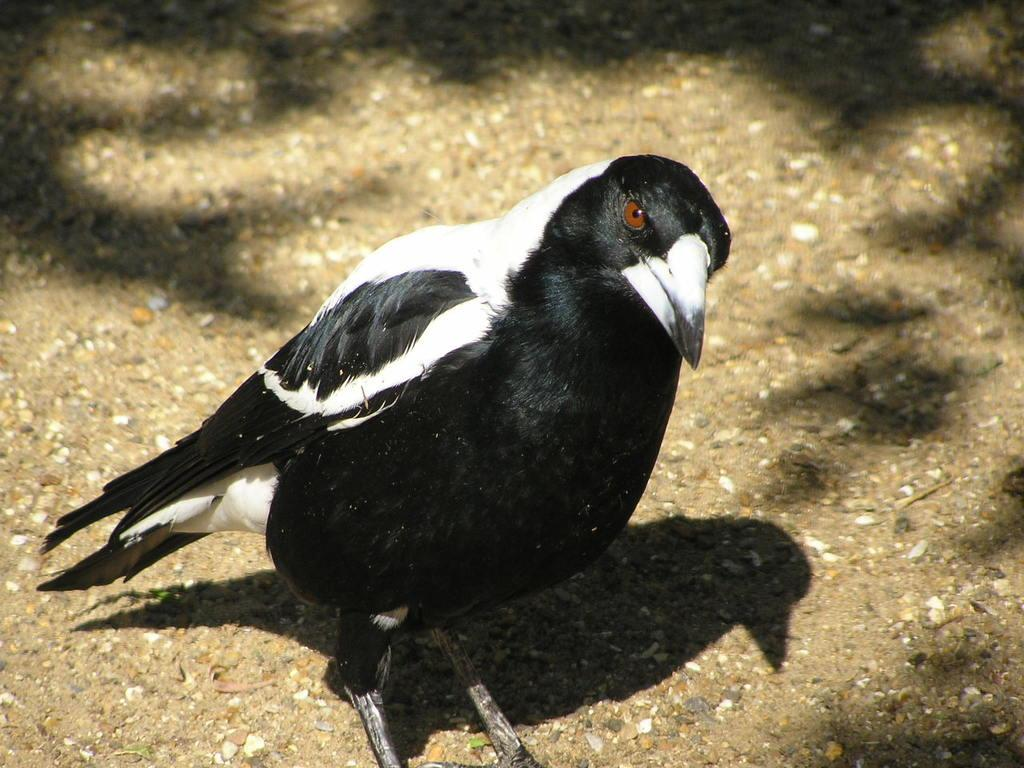What type of animal is present in the image? There is a bird in the image. What colors are present on the bird in the image? The bird is black and white in color. Where is the bird located in the image? The bird is on the land. What is the title of the book the bird is reading in the image? There is no book or reading activity present in the image; it features a bird on the land. What type of weapon is the bird holding in the image? There is no weapon present in the image; it features a bird on the land. 